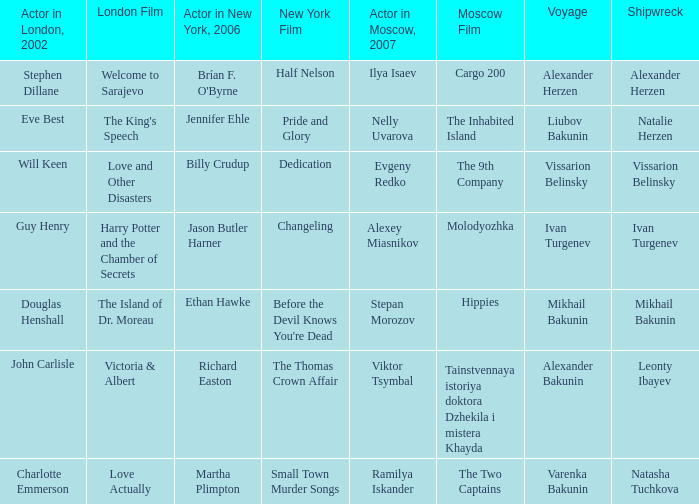Who was the Actor in the New York production in 2006 for the row with Ramilya Iskander performing in Moscow in 2007? Martha Plimpton. 